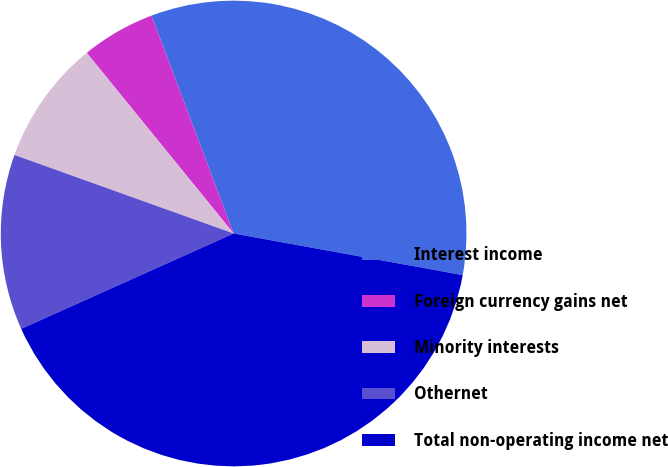<chart> <loc_0><loc_0><loc_500><loc_500><pie_chart><fcel>Interest income<fcel>Foreign currency gains net<fcel>Minority interests<fcel>Othernet<fcel>Total non-operating income net<nl><fcel>33.6%<fcel>5.13%<fcel>8.66%<fcel>12.19%<fcel>40.43%<nl></chart> 